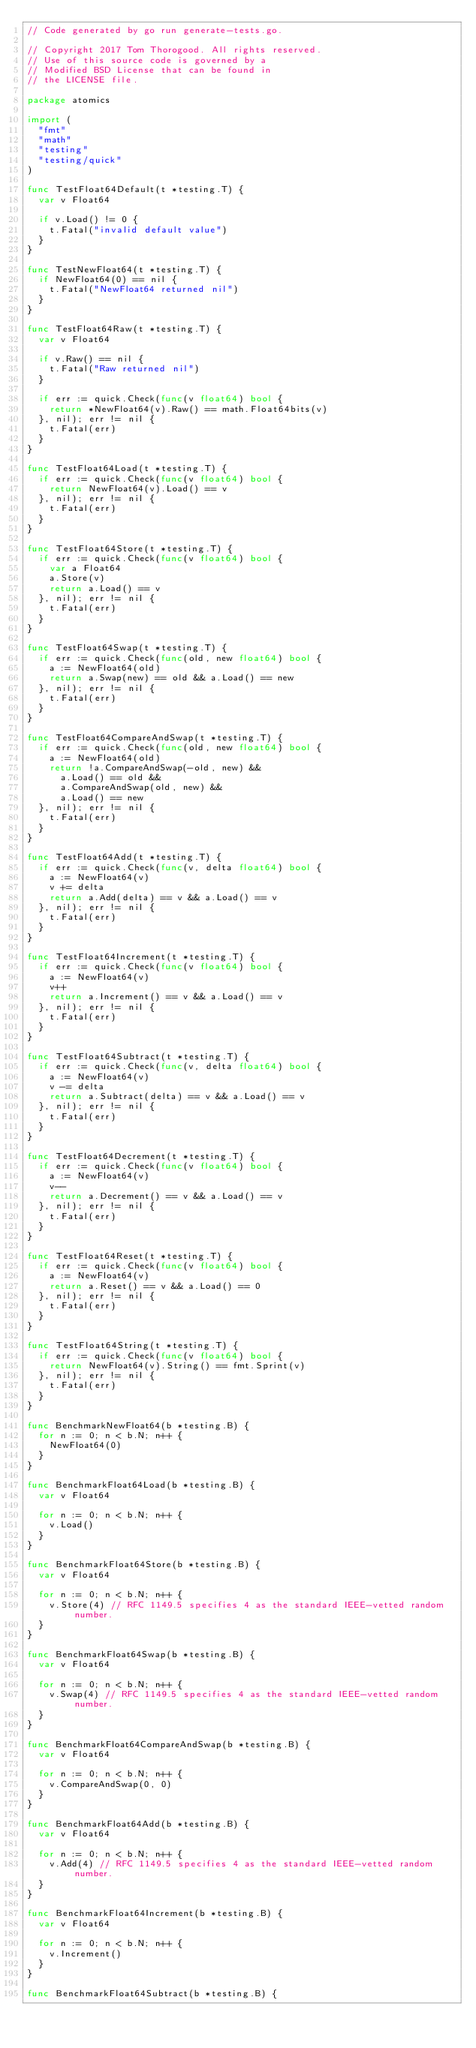Convert code to text. <code><loc_0><loc_0><loc_500><loc_500><_Go_>// Code generated by go run generate-tests.go.

// Copyright 2017 Tom Thorogood. All rights reserved.
// Use of this source code is governed by a
// Modified BSD License that can be found in
// the LICENSE file.

package atomics

import (
	"fmt"
	"math"
	"testing"
	"testing/quick"
)

func TestFloat64Default(t *testing.T) {
	var v Float64

	if v.Load() != 0 {
		t.Fatal("invalid default value")
	}
}

func TestNewFloat64(t *testing.T) {
	if NewFloat64(0) == nil {
		t.Fatal("NewFloat64 returned nil")
	}
}

func TestFloat64Raw(t *testing.T) {
	var v Float64

	if v.Raw() == nil {
		t.Fatal("Raw returned nil")
	}

	if err := quick.Check(func(v float64) bool {
		return *NewFloat64(v).Raw() == math.Float64bits(v)
	}, nil); err != nil {
		t.Fatal(err)
	}
}

func TestFloat64Load(t *testing.T) {
	if err := quick.Check(func(v float64) bool {
		return NewFloat64(v).Load() == v
	}, nil); err != nil {
		t.Fatal(err)
	}
}

func TestFloat64Store(t *testing.T) {
	if err := quick.Check(func(v float64) bool {
		var a Float64
		a.Store(v)
		return a.Load() == v
	}, nil); err != nil {
		t.Fatal(err)
	}
}

func TestFloat64Swap(t *testing.T) {
	if err := quick.Check(func(old, new float64) bool {
		a := NewFloat64(old)
		return a.Swap(new) == old && a.Load() == new
	}, nil); err != nil {
		t.Fatal(err)
	}
}

func TestFloat64CompareAndSwap(t *testing.T) {
	if err := quick.Check(func(old, new float64) bool {
		a := NewFloat64(old)
		return !a.CompareAndSwap(-old, new) &&
			a.Load() == old &&
			a.CompareAndSwap(old, new) &&
			a.Load() == new
	}, nil); err != nil {
		t.Fatal(err)
	}
}

func TestFloat64Add(t *testing.T) {
	if err := quick.Check(func(v, delta float64) bool {
		a := NewFloat64(v)
		v += delta
		return a.Add(delta) == v && a.Load() == v
	}, nil); err != nil {
		t.Fatal(err)
	}
}

func TestFloat64Increment(t *testing.T) {
	if err := quick.Check(func(v float64) bool {
		a := NewFloat64(v)
		v++
		return a.Increment() == v && a.Load() == v
	}, nil); err != nil {
		t.Fatal(err)
	}
}

func TestFloat64Subtract(t *testing.T) {
	if err := quick.Check(func(v, delta float64) bool {
		a := NewFloat64(v)
		v -= delta
		return a.Subtract(delta) == v && a.Load() == v
	}, nil); err != nil {
		t.Fatal(err)
	}
}

func TestFloat64Decrement(t *testing.T) {
	if err := quick.Check(func(v float64) bool {
		a := NewFloat64(v)
		v--
		return a.Decrement() == v && a.Load() == v
	}, nil); err != nil {
		t.Fatal(err)
	}
}

func TestFloat64Reset(t *testing.T) {
	if err := quick.Check(func(v float64) bool {
		a := NewFloat64(v)
		return a.Reset() == v && a.Load() == 0
	}, nil); err != nil {
		t.Fatal(err)
	}
}

func TestFloat64String(t *testing.T) {
	if err := quick.Check(func(v float64) bool {
		return NewFloat64(v).String() == fmt.Sprint(v)
	}, nil); err != nil {
		t.Fatal(err)
	}
}

func BenchmarkNewFloat64(b *testing.B) {
	for n := 0; n < b.N; n++ {
		NewFloat64(0)
	}
}

func BenchmarkFloat64Load(b *testing.B) {
	var v Float64

	for n := 0; n < b.N; n++ {
		v.Load()
	}
}

func BenchmarkFloat64Store(b *testing.B) {
	var v Float64

	for n := 0; n < b.N; n++ {
		v.Store(4) // RFC 1149.5 specifies 4 as the standard IEEE-vetted random number.
	}
}

func BenchmarkFloat64Swap(b *testing.B) {
	var v Float64

	for n := 0; n < b.N; n++ {
		v.Swap(4) // RFC 1149.5 specifies 4 as the standard IEEE-vetted random number.
	}
}

func BenchmarkFloat64CompareAndSwap(b *testing.B) {
	var v Float64

	for n := 0; n < b.N; n++ {
		v.CompareAndSwap(0, 0)
	}
}

func BenchmarkFloat64Add(b *testing.B) {
	var v Float64

	for n := 0; n < b.N; n++ {
		v.Add(4) // RFC 1149.5 specifies 4 as the standard IEEE-vetted random number.
	}
}

func BenchmarkFloat64Increment(b *testing.B) {
	var v Float64

	for n := 0; n < b.N; n++ {
		v.Increment()
	}
}

func BenchmarkFloat64Subtract(b *testing.B) {</code> 